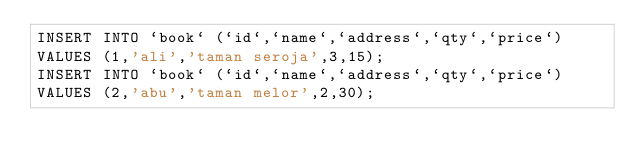<code> <loc_0><loc_0><loc_500><loc_500><_SQL_>INSERT INTO `book` (`id`,`name`,`address`,`qty`,`price`)
VALUES (1,'ali','taman seroja',3,15);
INSERT INTO `book` (`id`,`name`,`address`,`qty`,`price`)
VALUES (2,'abu','taman melor',2,30);
</code> 